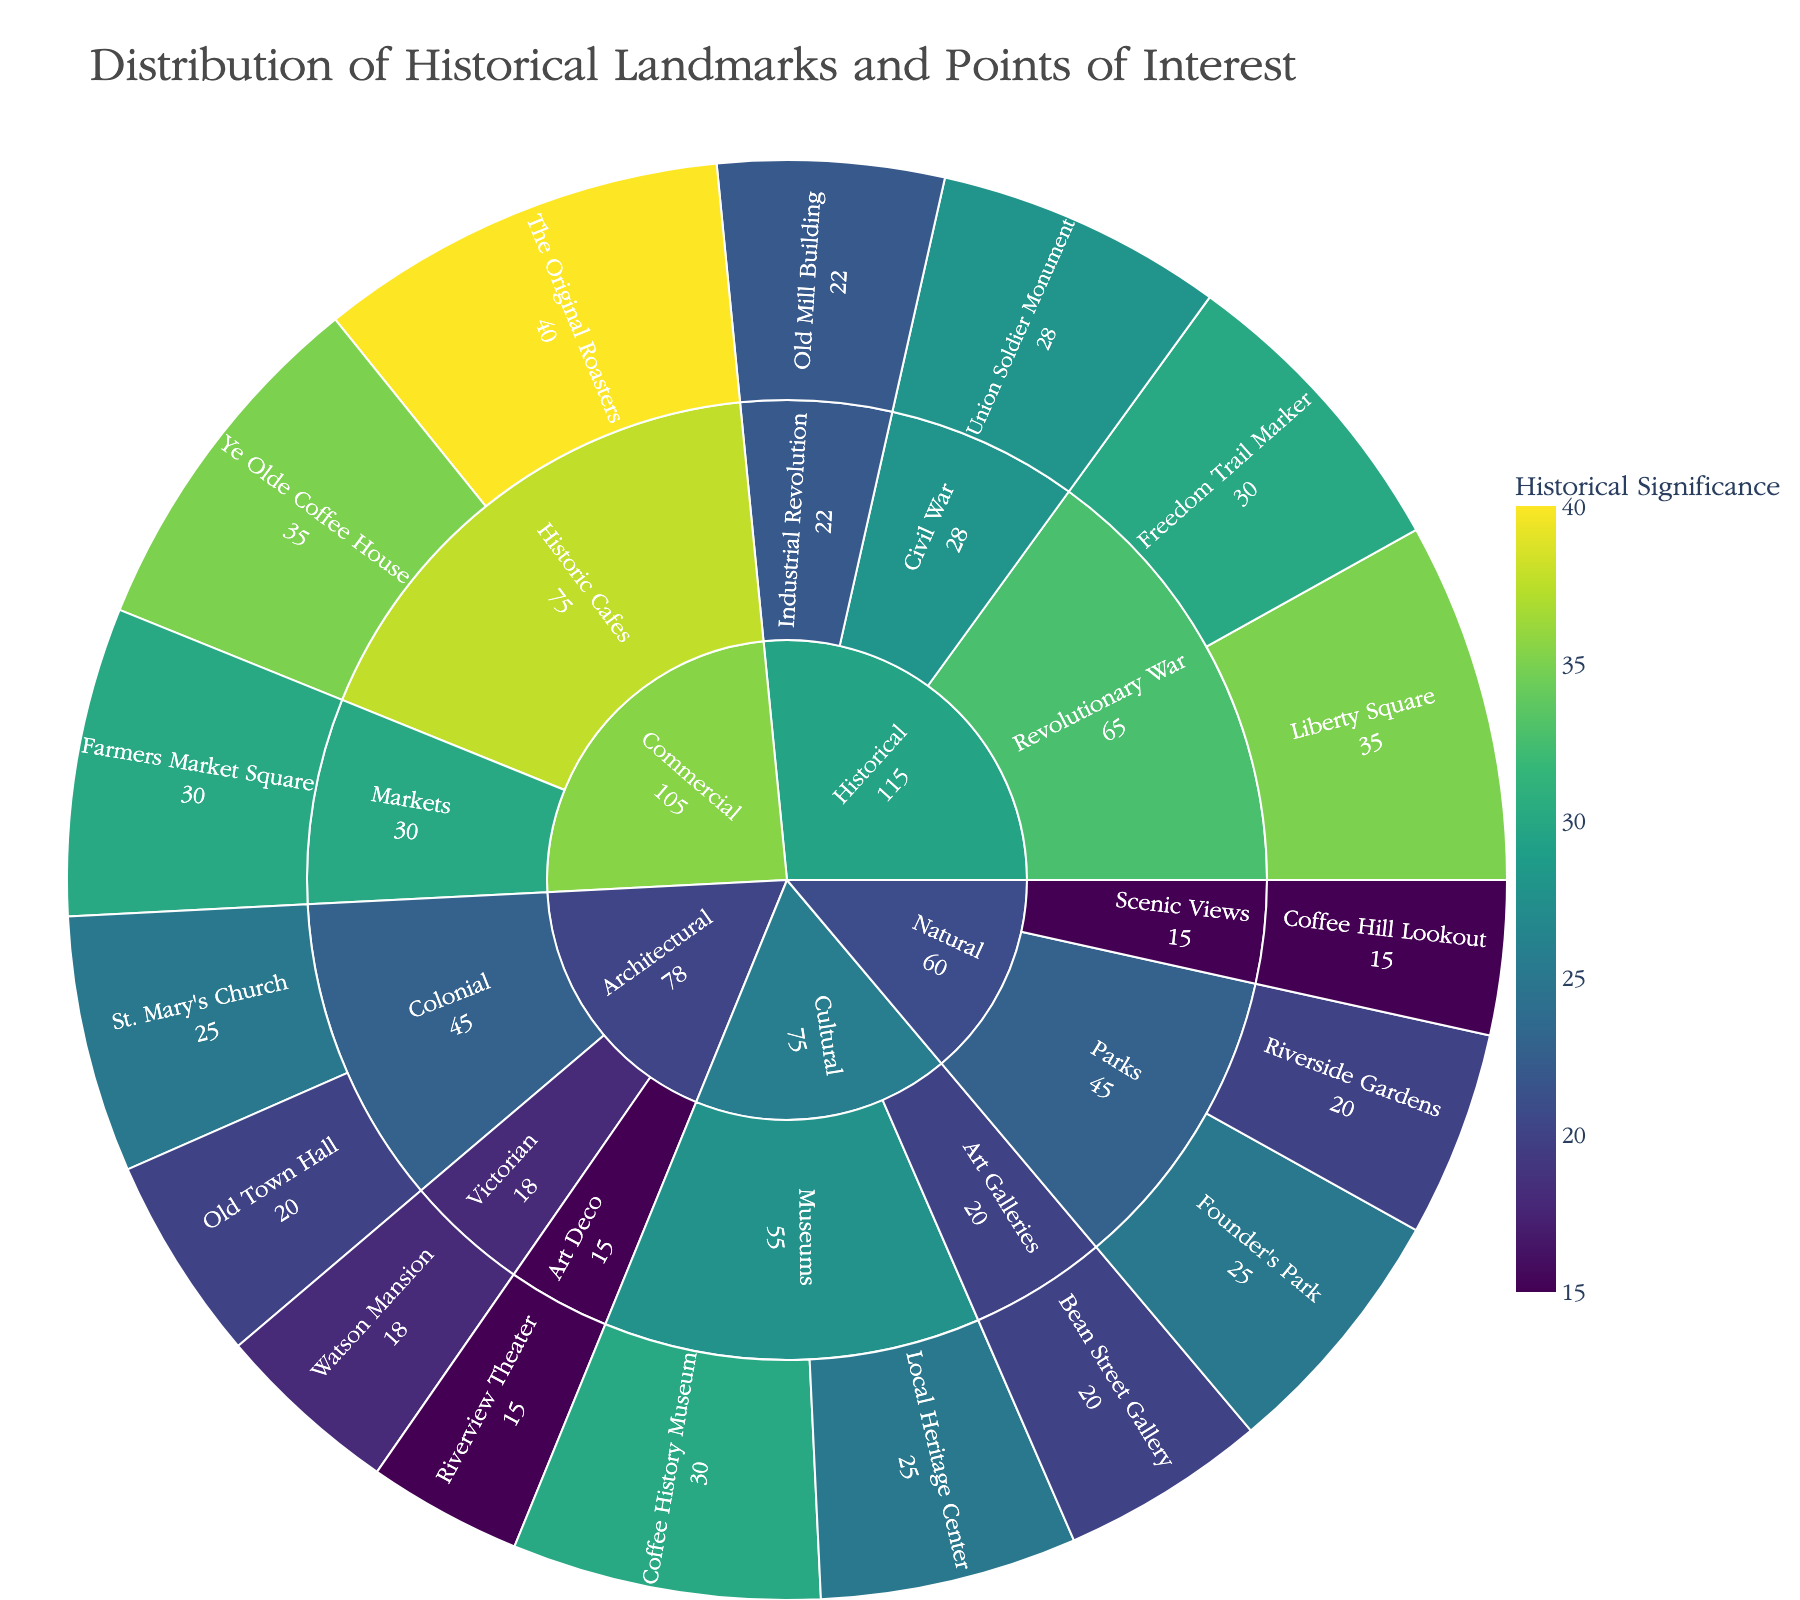What's the title of the Sunburst Plot? The title of a graph typically indicates what the data is about. In this case, at the top of the Sunburst Plot, it states the topic being visualized.
Answer: "Distribution of Historical Landmarks and Points of Interest" How many subcategories does the 'Architectural' category contain? The 'Architectural' category expands into subcategories which can be seen as branches from the main category in the Sunburst Plot. Count the branches directly connected to 'Architectural'.
Answer: 3 Which point of interest has the highest historical significance value? Look through the plot for the point with the largest segment. The segment with the largest size indicates the highest value.
Answer: "The Original Roasters" with a value of 40 What is the combined historical significance of all 'Cultural' subcategories? Sum the values of all points of interest under 'Cultural' subcategories by looking at the individual segments and adding their values together.
Answer: 75 (30 + 25 for Museums, 20 for Art Galleries) What is the difference in historical significance between ‘Liberty Square’ and the 'Union Soldier Monument'? Identify the values associated with 'Liberty Square' and 'Union Soldier Monument' and calculate the difference.
Answer: 7 (35 - 28) Which subcategory under ‘Historical’ has the smallest total value? Look under the ‘Historical’ category and compare the total values of each subcategory. The subcategory with the smallest sum of individual values is the answer.
Answer: "Industrial Revolution" with 22 What is the average historical significance of all landmarks under the 'Natural' category? Add up all the values under the 'Natural' category and divide by the number of landmarks to get the average.
Answer: 20 ((25 + 20 + 15) / 3) Which has more points of interest: 'Commercial' or 'Historical'? Count the number of leaf nodes (individual points of interest) under 'Commercial' and compare that with the count under 'Historical'.
Answer: Historical with 4 points (as opposed to 3 for Commercial) What color scale is used for the historical significance in the plot? The color scheme for the plot usually follows a consistent pattern, which can be seen in the legend. Identify the gradient used.
Answer: Viridis What is the total value of 'Commercial' category? Sum the values of all points of interest under the 'Commercial' category by looking at the individual segments and adding them together.
Answer: 105 (40 + 35 + 30) 